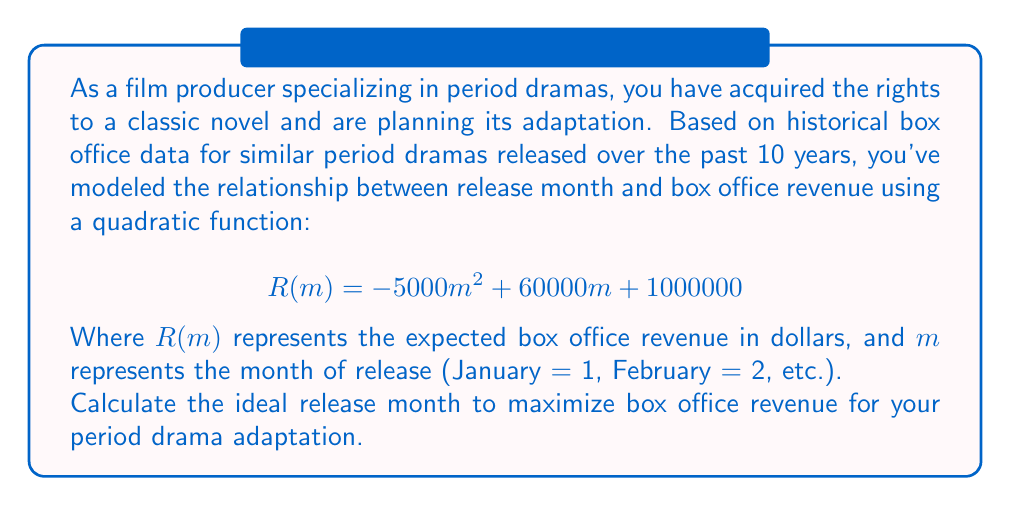Show me your answer to this math problem. To find the ideal release month that maximizes box office revenue, we need to find the maximum of the quadratic function $R(m)$. The steps to solve this problem are as follows:

1. Recognize that the function is in the form of a quadratic equation:
   $$R(m) = -5000m^2 + 60000m + 1000000$$

2. For a quadratic function in the form $f(x) = ax^2 + bx + c$, the x-coordinate of the vertex (which gives the maximum or minimum) is given by the formula:
   $$x = -\frac{b}{2a}$$

3. In our case, $a = -5000$ and $b = 60000$. Let's substitute these values:
   $$m = -\frac{60000}{2(-5000)} = -\frac{60000}{-10000} = 6$$

4. Since $m$ represents months, and we can't have a fractional month, we need to round to the nearest whole number. In this case, 6 is already a whole number.

5. To verify this is a maximum (not a minimum), we can check that $a < 0$, which it is ($a = -5000$).

6. Therefore, the 6th month (June) is the ideal release month to maximize box office revenue.

7. We can calculate the expected revenue for this month:
   $$R(6) = -5000(6^2) + 60000(6) + 1000000$$
   $$= -180000 + 360000 + 1000000 = 1180000$$

So, releasing in June is expected to generate $1,180,000 in box office revenue.
Answer: The ideal release month to maximize box office revenue is June (month 6), with an expected revenue of $1,180,000. 